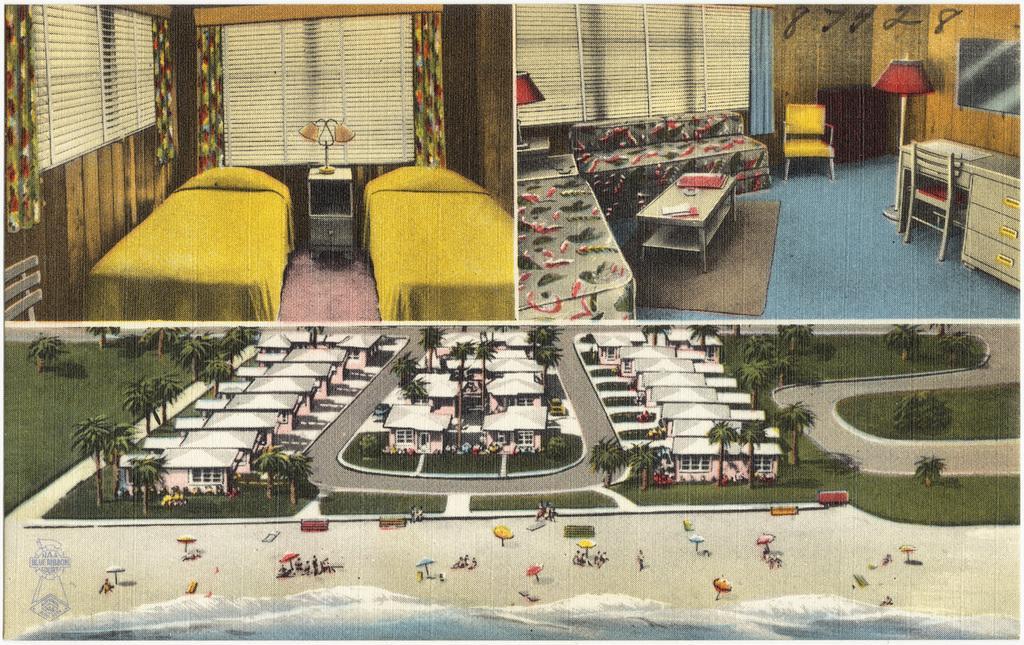Describe this image in one or two sentences. In this image we can see three pictures. In the first picture we can see two beds with pillows and yellow color bed sheets, we can see table lamp, window blinds, chair, curtains and the wooden wall. In the second picture we can see sofa, table, chairs, cupboards, table lamps, curtains, window blinds and the wooden wall in the background. In the third picture we can see houses, trees, way, chairs, umbrellas, grass and the beach. Here we can see the watermark. 